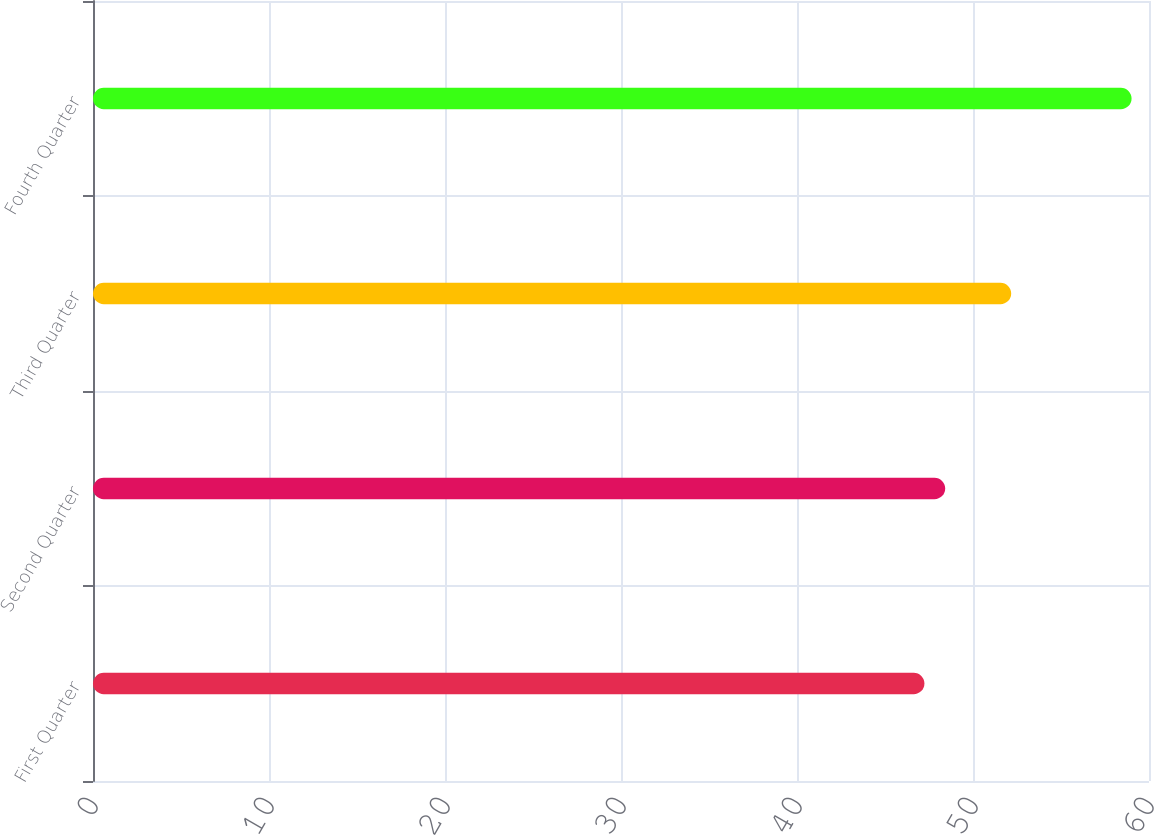<chart> <loc_0><loc_0><loc_500><loc_500><bar_chart><fcel>First Quarter<fcel>Second Quarter<fcel>Third Quarter<fcel>Fourth Quarter<nl><fcel>47.24<fcel>48.42<fcel>52.17<fcel>59.01<nl></chart> 